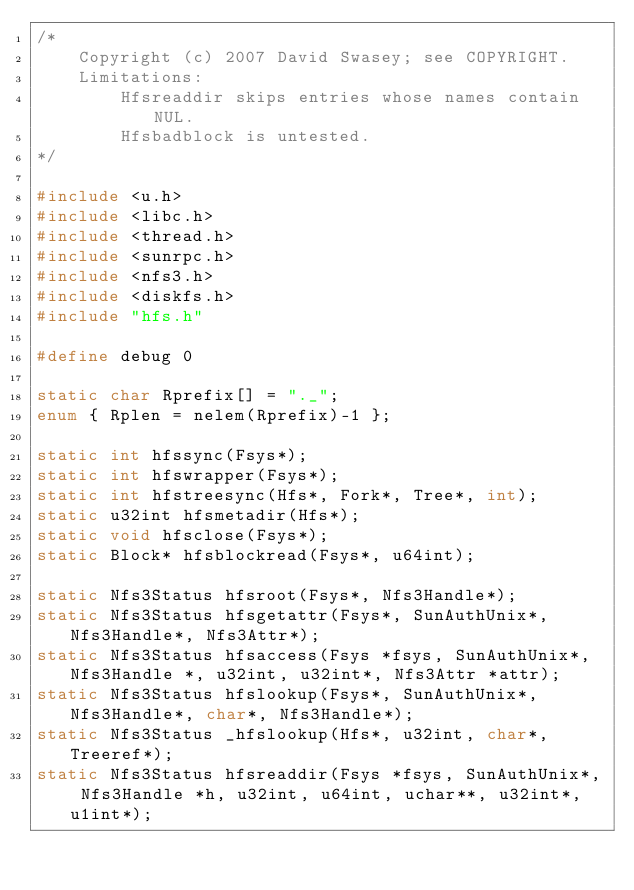Convert code to text. <code><loc_0><loc_0><loc_500><loc_500><_C_>/*
	Copyright (c) 2007 David Swasey; see COPYRIGHT.
	Limitations:
		Hfsreaddir skips entries whose names contain NUL.
		Hfsbadblock is untested.
*/

#include <u.h>
#include <libc.h>
#include <thread.h>
#include <sunrpc.h>
#include <nfs3.h>
#include <diskfs.h>
#include "hfs.h"

#define debug 0

static char Rprefix[] = "._";
enum { Rplen = nelem(Rprefix)-1 };

static int hfssync(Fsys*);
static int hfswrapper(Fsys*);
static int hfstreesync(Hfs*, Fork*, Tree*, int);
static u32int hfsmetadir(Hfs*);
static void hfsclose(Fsys*);
static Block* hfsblockread(Fsys*, u64int);

static Nfs3Status hfsroot(Fsys*, Nfs3Handle*);
static Nfs3Status hfsgetattr(Fsys*, SunAuthUnix*, Nfs3Handle*, Nfs3Attr*);
static Nfs3Status hfsaccess(Fsys *fsys, SunAuthUnix*, Nfs3Handle *, u32int, u32int*, Nfs3Attr *attr);
static Nfs3Status hfslookup(Fsys*, SunAuthUnix*, Nfs3Handle*, char*, Nfs3Handle*);
static Nfs3Status _hfslookup(Hfs*, u32int, char*, Treeref*);
static Nfs3Status hfsreaddir(Fsys *fsys, SunAuthUnix*, Nfs3Handle *h, u32int, u64int, uchar**, u32int*, u1int*);</code> 